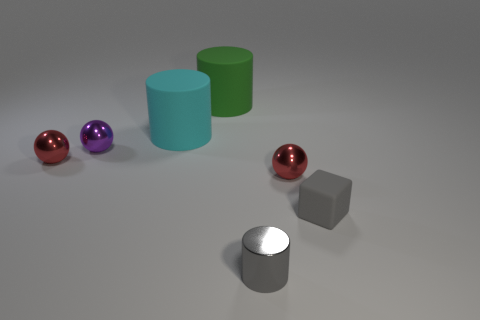Subtract all blue blocks. Subtract all brown cylinders. How many blocks are left? 1 Add 2 purple metal things. How many objects exist? 9 Subtract all cylinders. How many objects are left? 4 Add 2 brown metal cubes. How many brown metal cubes exist? 2 Subtract 0 green blocks. How many objects are left? 7 Subtract all purple metal spheres. Subtract all big green rubber cylinders. How many objects are left? 5 Add 5 green matte cylinders. How many green matte cylinders are left? 6 